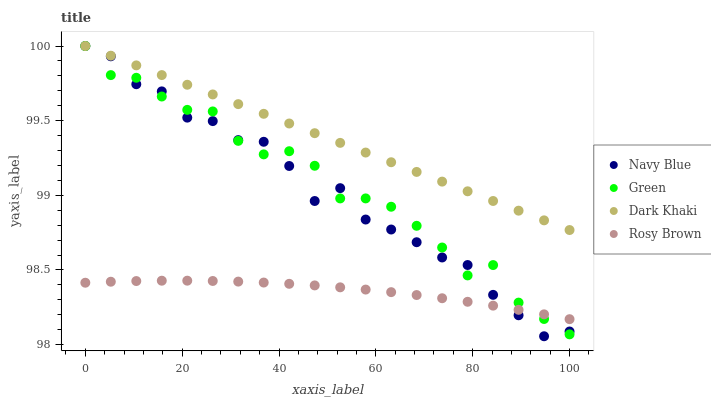Does Rosy Brown have the minimum area under the curve?
Answer yes or no. Yes. Does Dark Khaki have the maximum area under the curve?
Answer yes or no. Yes. Does Navy Blue have the minimum area under the curve?
Answer yes or no. No. Does Navy Blue have the maximum area under the curve?
Answer yes or no. No. Is Dark Khaki the smoothest?
Answer yes or no. Yes. Is Navy Blue the roughest?
Answer yes or no. Yes. Is Rosy Brown the smoothest?
Answer yes or no. No. Is Rosy Brown the roughest?
Answer yes or no. No. Does Navy Blue have the lowest value?
Answer yes or no. Yes. Does Rosy Brown have the lowest value?
Answer yes or no. No. Does Green have the highest value?
Answer yes or no. Yes. Does Rosy Brown have the highest value?
Answer yes or no. No. Is Rosy Brown less than Dark Khaki?
Answer yes or no. Yes. Is Dark Khaki greater than Rosy Brown?
Answer yes or no. Yes. Does Green intersect Dark Khaki?
Answer yes or no. Yes. Is Green less than Dark Khaki?
Answer yes or no. No. Is Green greater than Dark Khaki?
Answer yes or no. No. Does Rosy Brown intersect Dark Khaki?
Answer yes or no. No. 